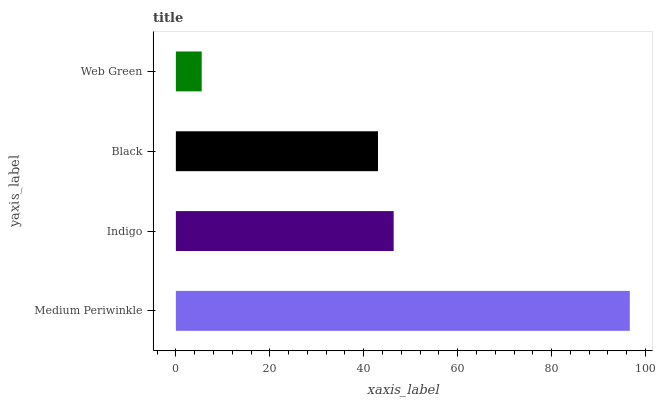Is Web Green the minimum?
Answer yes or no. Yes. Is Medium Periwinkle the maximum?
Answer yes or no. Yes. Is Indigo the minimum?
Answer yes or no. No. Is Indigo the maximum?
Answer yes or no. No. Is Medium Periwinkle greater than Indigo?
Answer yes or no. Yes. Is Indigo less than Medium Periwinkle?
Answer yes or no. Yes. Is Indigo greater than Medium Periwinkle?
Answer yes or no. No. Is Medium Periwinkle less than Indigo?
Answer yes or no. No. Is Indigo the high median?
Answer yes or no. Yes. Is Black the low median?
Answer yes or no. Yes. Is Medium Periwinkle the high median?
Answer yes or no. No. Is Medium Periwinkle the low median?
Answer yes or no. No. 